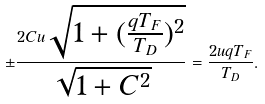<formula> <loc_0><loc_0><loc_500><loc_500>\pm \frac { 2 C u \sqrt { 1 + ( \frac { q T _ { F } } { T _ { D } } ) ^ { 2 } } } { \sqrt { 1 + C ^ { 2 } } } = \frac { 2 u q T _ { F } } { T _ { D } } .</formula> 